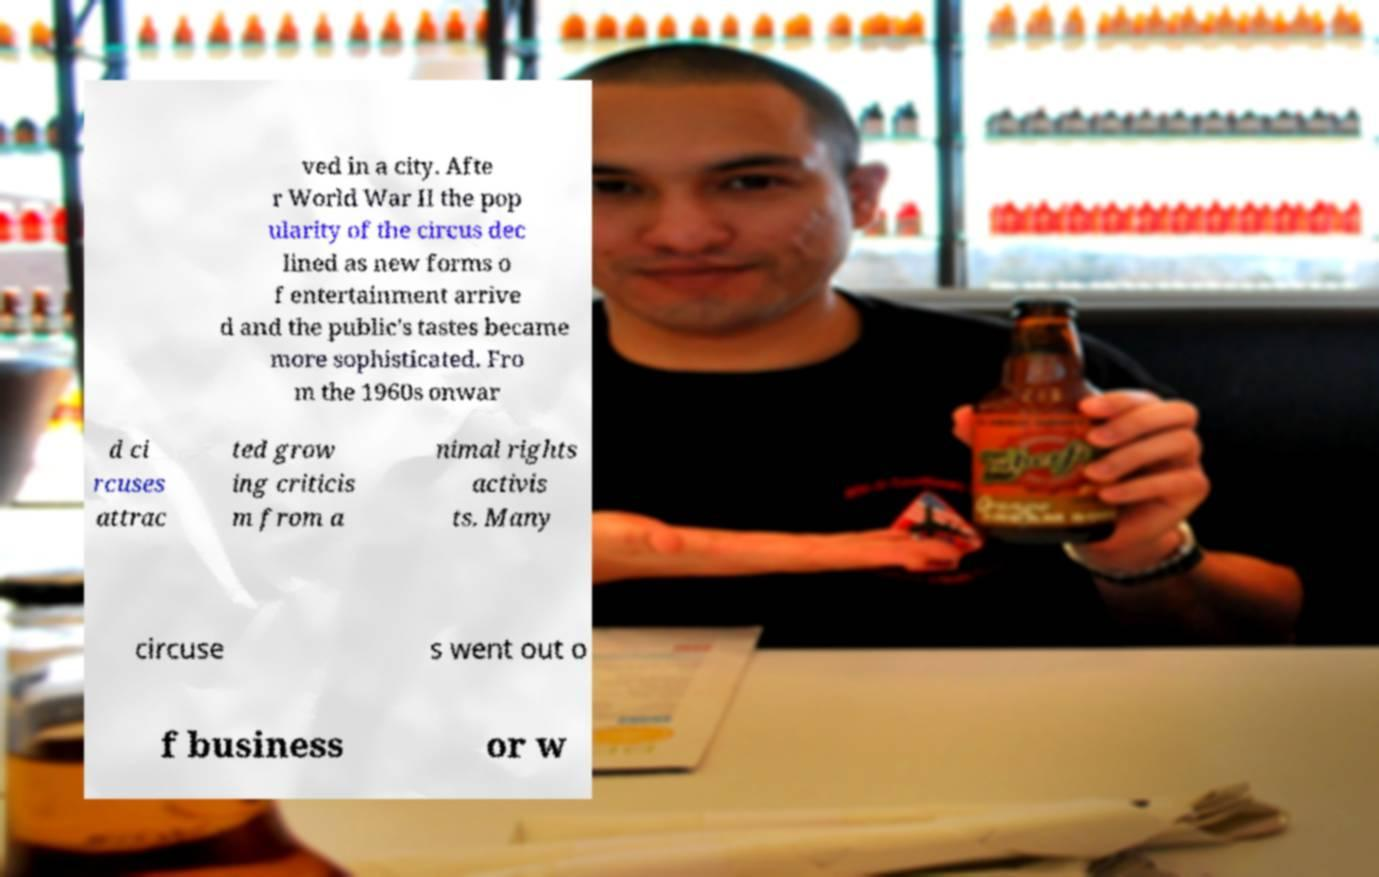There's text embedded in this image that I need extracted. Can you transcribe it verbatim? ved in a city. Afte r World War II the pop ularity of the circus dec lined as new forms o f entertainment arrive d and the public's tastes became more sophisticated. Fro m the 1960s onwar d ci rcuses attrac ted grow ing criticis m from a nimal rights activis ts. Many circuse s went out o f business or w 